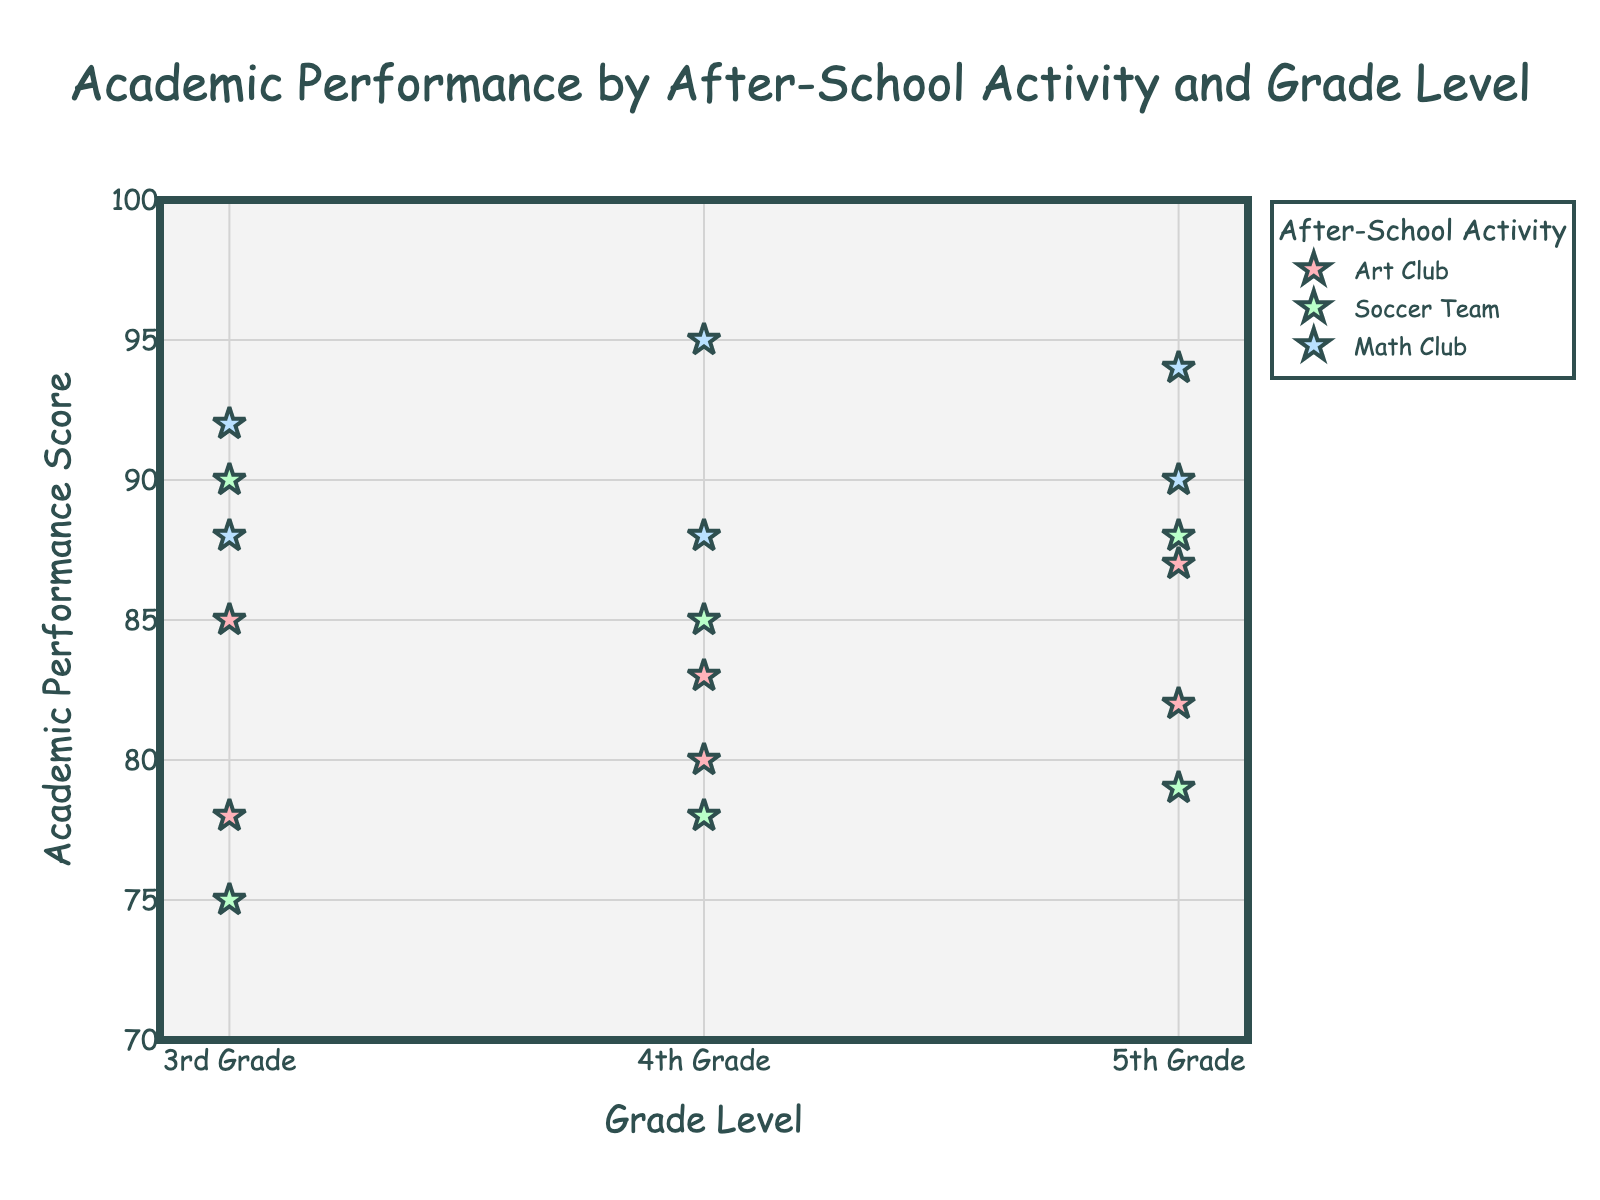What is the title of the graph? The title of the graph is shown at the top and summarizes what the graph is about.
Answer: Academic Performance by After-School Activity and Grade Level What color represents the Math Club activity? The Math Club activity is represented by a unique color in the legend of the graph.
Answer: Light blue How many students are in the 3rd Grade? Count the number of data points on the graph that align with the 3rd Grade on the x-axis.
Answer: 6 Which after-school activity has the highest average academic performance in the 4th Grade? Look at the data points for the 4th Grade, group them by after-school activity, and calculate the average performance for each group.
Answer: Math Club Compare the academic performance of Art Club participants across all grades. Which grade has the highest performing Art Club participants? Inspect the data points for Art Club participants in each grade (3rd, 4th, and 5th). Compare the academic performance scores and identify the grade with the highest scores.
Answer: 5th Grade What is the range of academic performance scores in the 5th Grade? Identify the lowest and highest academic performance scores in the 5th Grade, then calculate the difference between them.
Answer: 79 to 94 How does the academic performance of the Soccer Team compare between 3rd and 5th Grades? Identify the data points for Soccer Team members in 3rd and 5th Grades. Compare the scores to see if one grade performs better.
Answer: 5th Grade performs better Which student scored the highest on the Math Club in the 3rd Grade? Look at the data points for the Math Club in the 3rd Grade and identify the student with the highest academic performance score.
Answer: Carol Brown What are the average academic performances of students in each after-school activity across all grades? Group the data points by after-school activity and calculate the average academic performance score for each group.
Answer: Art Club: 82.5, Soccer Team: 84.2, Math Club: 91.2 Is there a noticeable trend in academic performance as students progress from 3rd to 5th Grade in any after-school activity? Observe the patterns of data points for each after-school activity across grades 3 to 5. Determine if there is a trend of improvement or decline in academic performance.
Answer: Math Club shows consistently high performance; Art Club shows a slight increase 